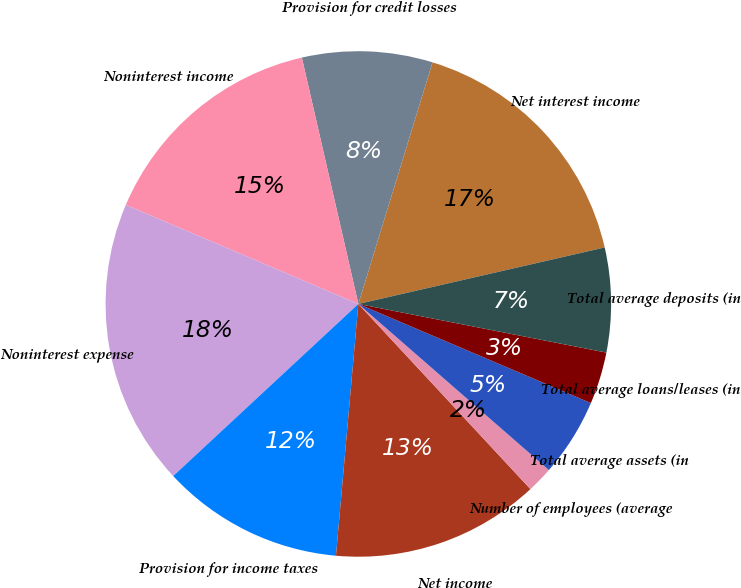<chart> <loc_0><loc_0><loc_500><loc_500><pie_chart><fcel>Net interest income<fcel>Provision for credit losses<fcel>Noninterest income<fcel>Noninterest expense<fcel>Provision for income taxes<fcel>Net income<fcel>Number of employees (average<fcel>Total average assets (in<fcel>Total average loans/leases (in<fcel>Total average deposits (in<nl><fcel>16.67%<fcel>8.33%<fcel>15.0%<fcel>18.33%<fcel>11.67%<fcel>13.33%<fcel>1.67%<fcel>5.0%<fcel>3.33%<fcel>6.67%<nl></chart> 